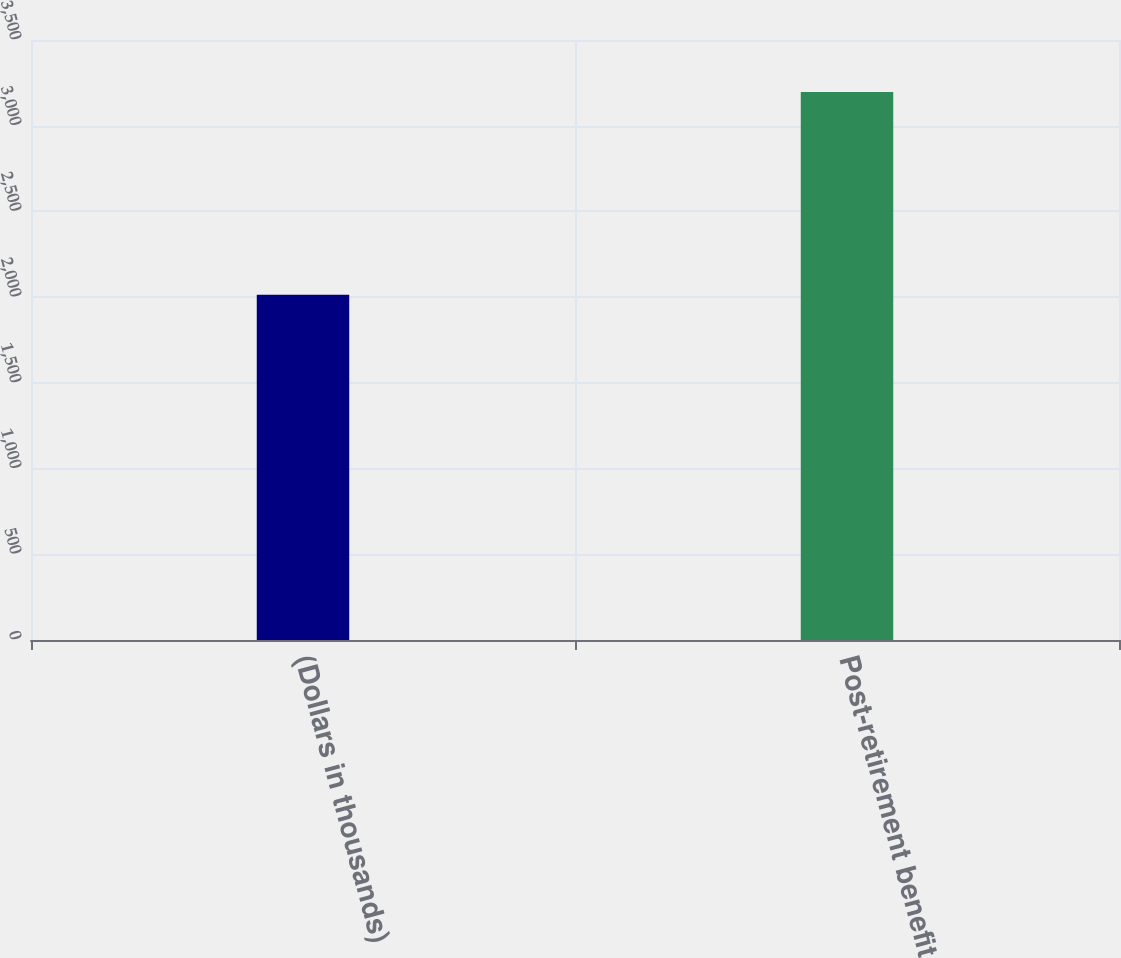Convert chart. <chart><loc_0><loc_0><loc_500><loc_500><bar_chart><fcel>(Dollars in thousands)<fcel>Post-retirement benefit<nl><fcel>2014<fcel>3196<nl></chart> 